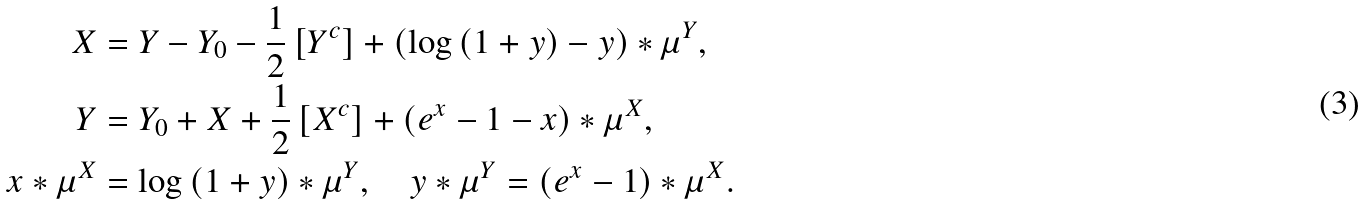Convert formula to latex. <formula><loc_0><loc_0><loc_500><loc_500>X & = Y - Y _ { 0 } - \frac { 1 } { 2 } \left [ Y ^ { c } \right ] + \left ( \log \left ( 1 + y \right ) - y \right ) \ast \mu ^ { Y } , \\ Y & = Y _ { 0 } + X + \frac { 1 } { 2 } \left [ X ^ { c } \right ] + \left ( e ^ { x } - 1 - x \right ) \ast \mu ^ { X } , \\ \quad x \ast \mu ^ { X } & = \log \left ( 1 + y \right ) \ast \mu ^ { Y } , \quad y \ast \mu ^ { Y } = \left ( e ^ { x } - 1 \right ) \ast \mu ^ { X } .</formula> 